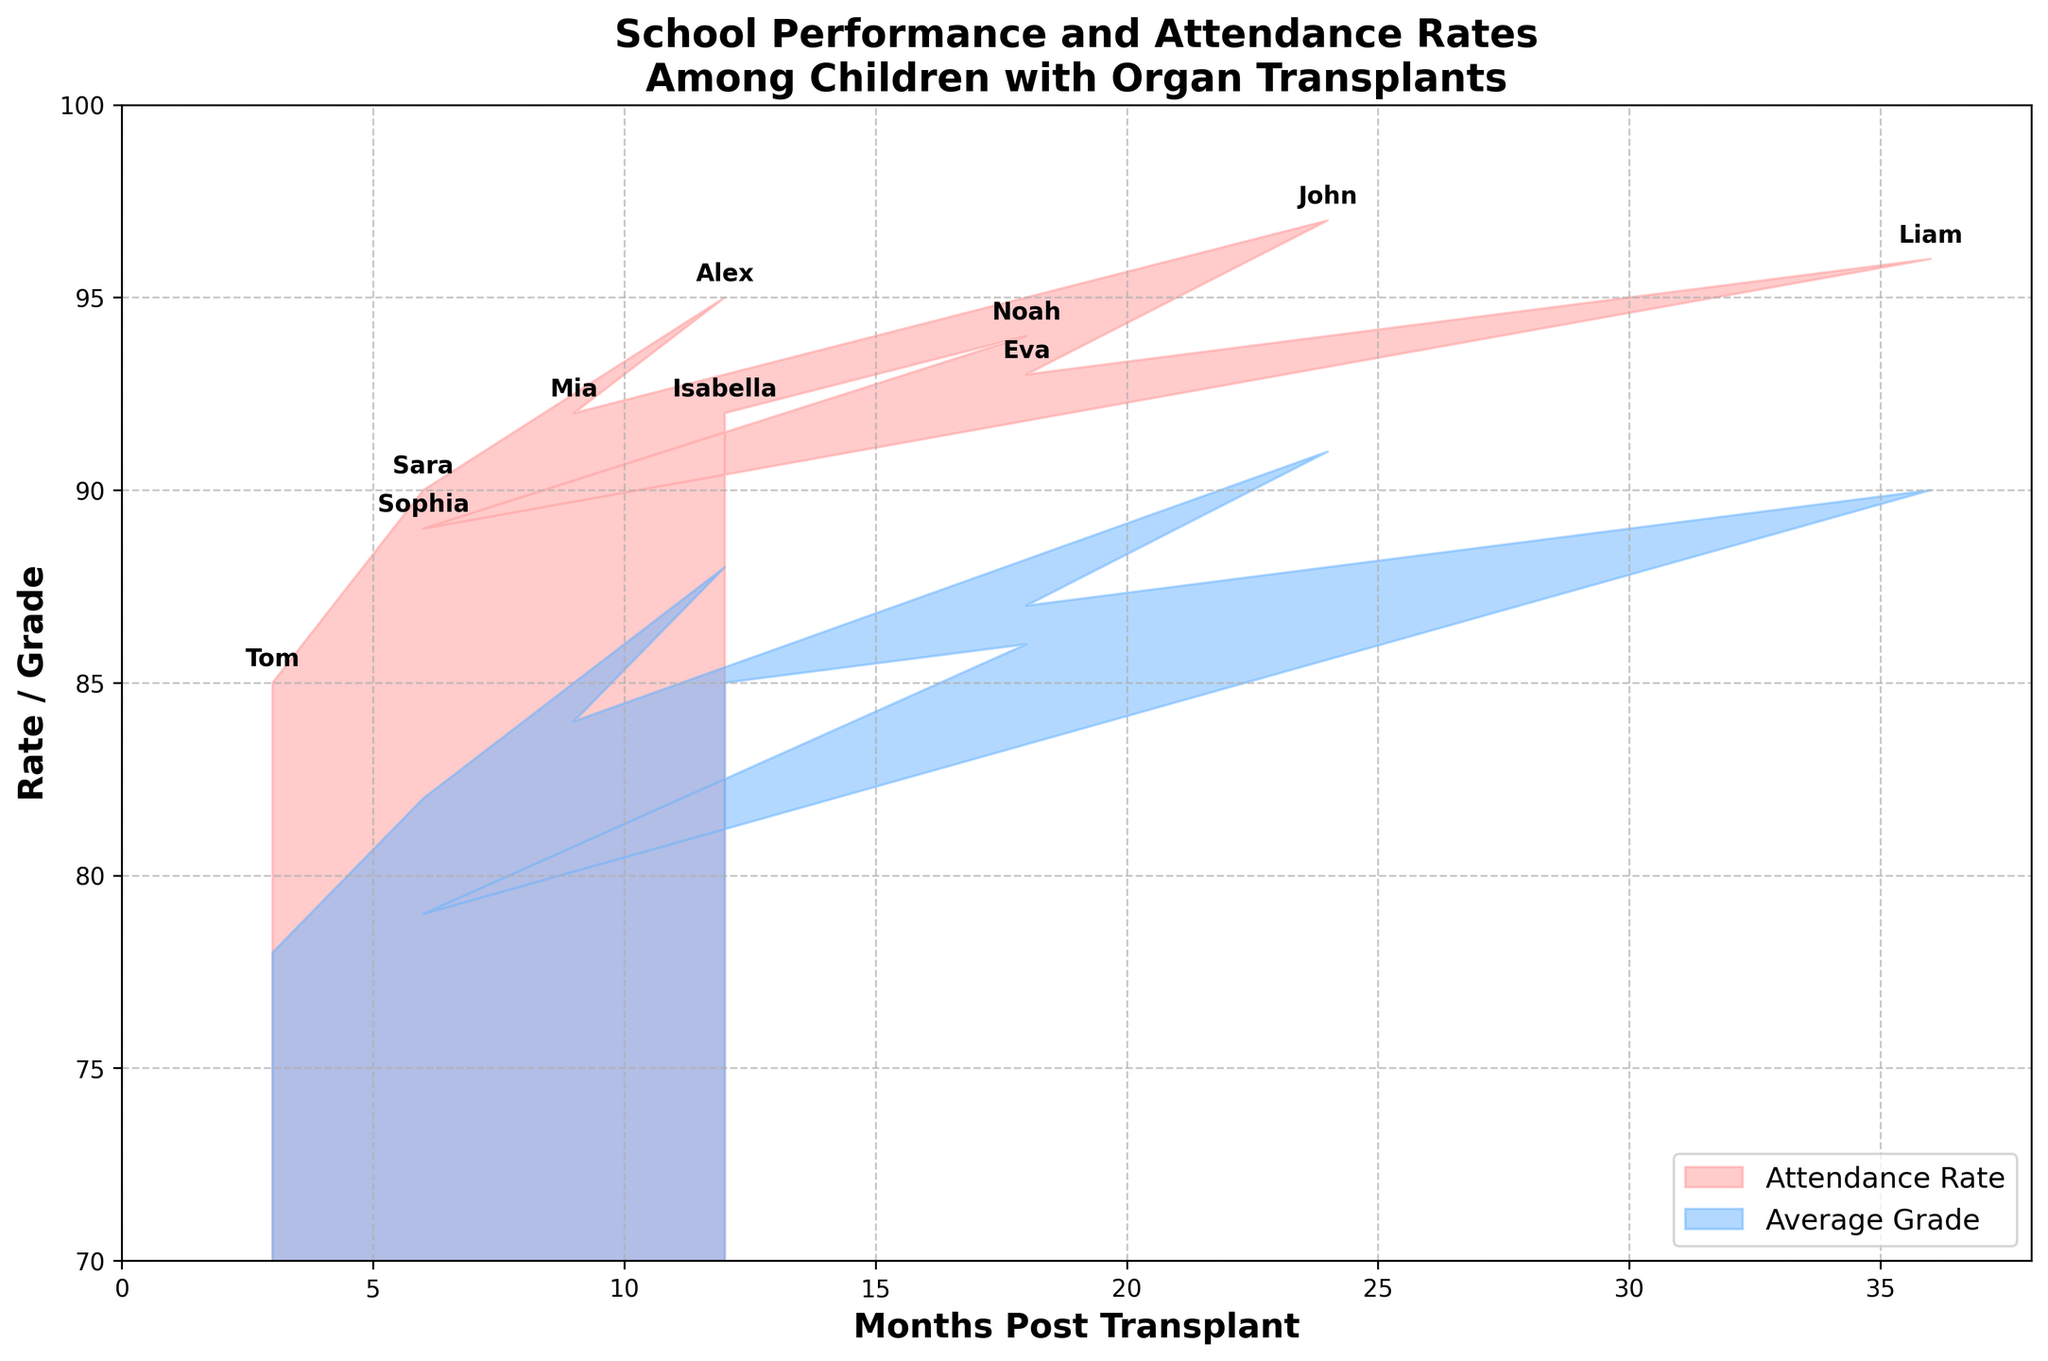What's the title of the figure? The title of the figure is positioned at the top of the chart and is clearly labeled. It reads "School Performance and Attendance Rates Among Children with Organ Transplants".
Answer: School Performance and Attendance Rates Among Children with Organ Transplants Which color is used to represent the 'Attendance Rate'? The 'Attendance Rate' is filled with a color that has a pinkish tint. This can be observed in the area labeled with the attendance rate.
Answer: Pinkish What is the x-axis labeled as? The x-axis label is found below the horizontal axis. It is labeled as "Months Post Transplant".
Answer: Months Post Transplant Between "Sara" and "Sophia", who has a higher attendance rate? Comparing the filled areas for both students, Sara's attendance rate is visible around 90%, whereas Sophia's attendance rate is around 89%. Hence, Sara has a higher attendance rate.
Answer: Sara What's the lowest average grade displayed on the chart? By examining the filled areas, the lowest average grade can be identified as slightly below 80%, near 78%.
Answer: 78% Which student has the highest average grade, and what is it? The student with the highest average grade is observed by finding the peak in the blue-filled area. John's name is annotated at a position indicating an average grade of around 91%.
Answer: John How many students' names are annotated on the chart? By counting the number of annotations, each representing a student, there are clearly 10 names displayed.
Answer: 10 What is the range of the 'Months Post Transplant' displayed on the x-axis? The x-axis starts at 0 and extends slightly beyond 36. The range is from 0 to around 38 months.
Answer: 0 to 38 Compare the 'Attendance Rate' and 'Average Grade' areas for the student with the longest time post-transplant. The longest time post-transplant is 36 months, belonging to Liam. Both the attendance rate and average grade for Liam are very close, with attendance around 96% and grade around 90%.
Answer: Attendance: 96%, Grade: 90% For which range of 'Months Post Transplant' do both 'Attendance Rate' and 'Average Grade' overlap the most? Observing the filled areas where they most closely match across the same range of months, the overlap appears most significant between 12 and 24 months.
Answer: 12 to 24 months 